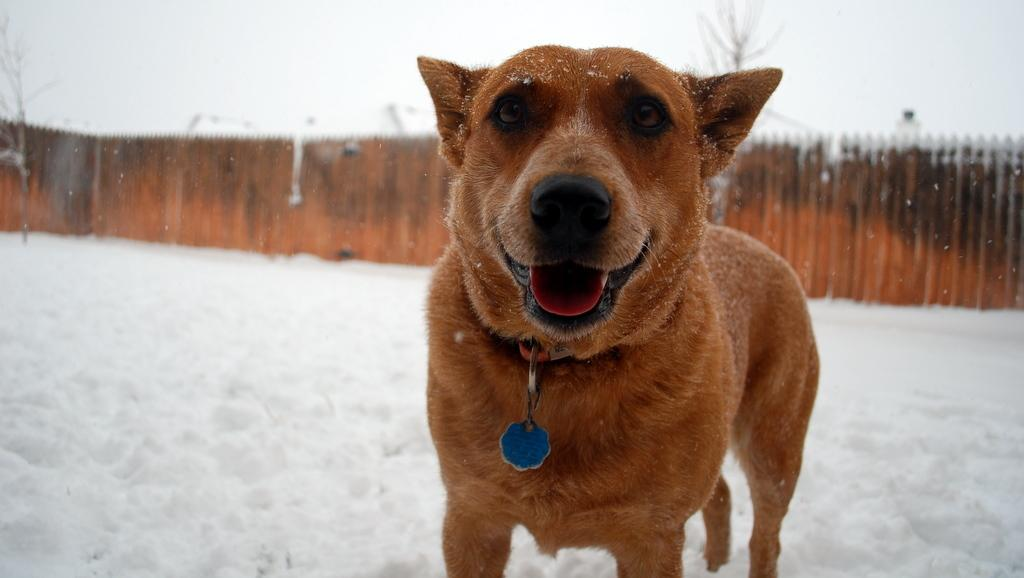What animal is present in the image? There is a dog in the image. What is the color of the dog? The dog is brown in color. Where is the dog located in the image? The dog is on the snow. What can be seen in the background of the image? There is a wooden fence, trees, and the sky visible in the background of the image. What type of yarn is the dog using to knit a sweater in the image? There is no yarn or sweater present in the image; it features a brown dog on the snow. What kind of party is happening in the background of the image? There is no party visible in the image; it shows a dog on the snow with a wooden fence, trees, and the sky in the background. 